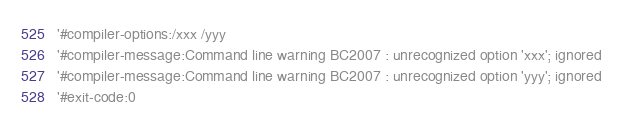<code> <loc_0><loc_0><loc_500><loc_500><_VisualBasic_>'#compiler-options:/xxx /yyy
'#compiler-message:Command line warning BC2007 : unrecognized option 'xxx'; ignored
'#compiler-message:Command line warning BC2007 : unrecognized option 'yyy'; ignored
'#exit-code:0</code> 